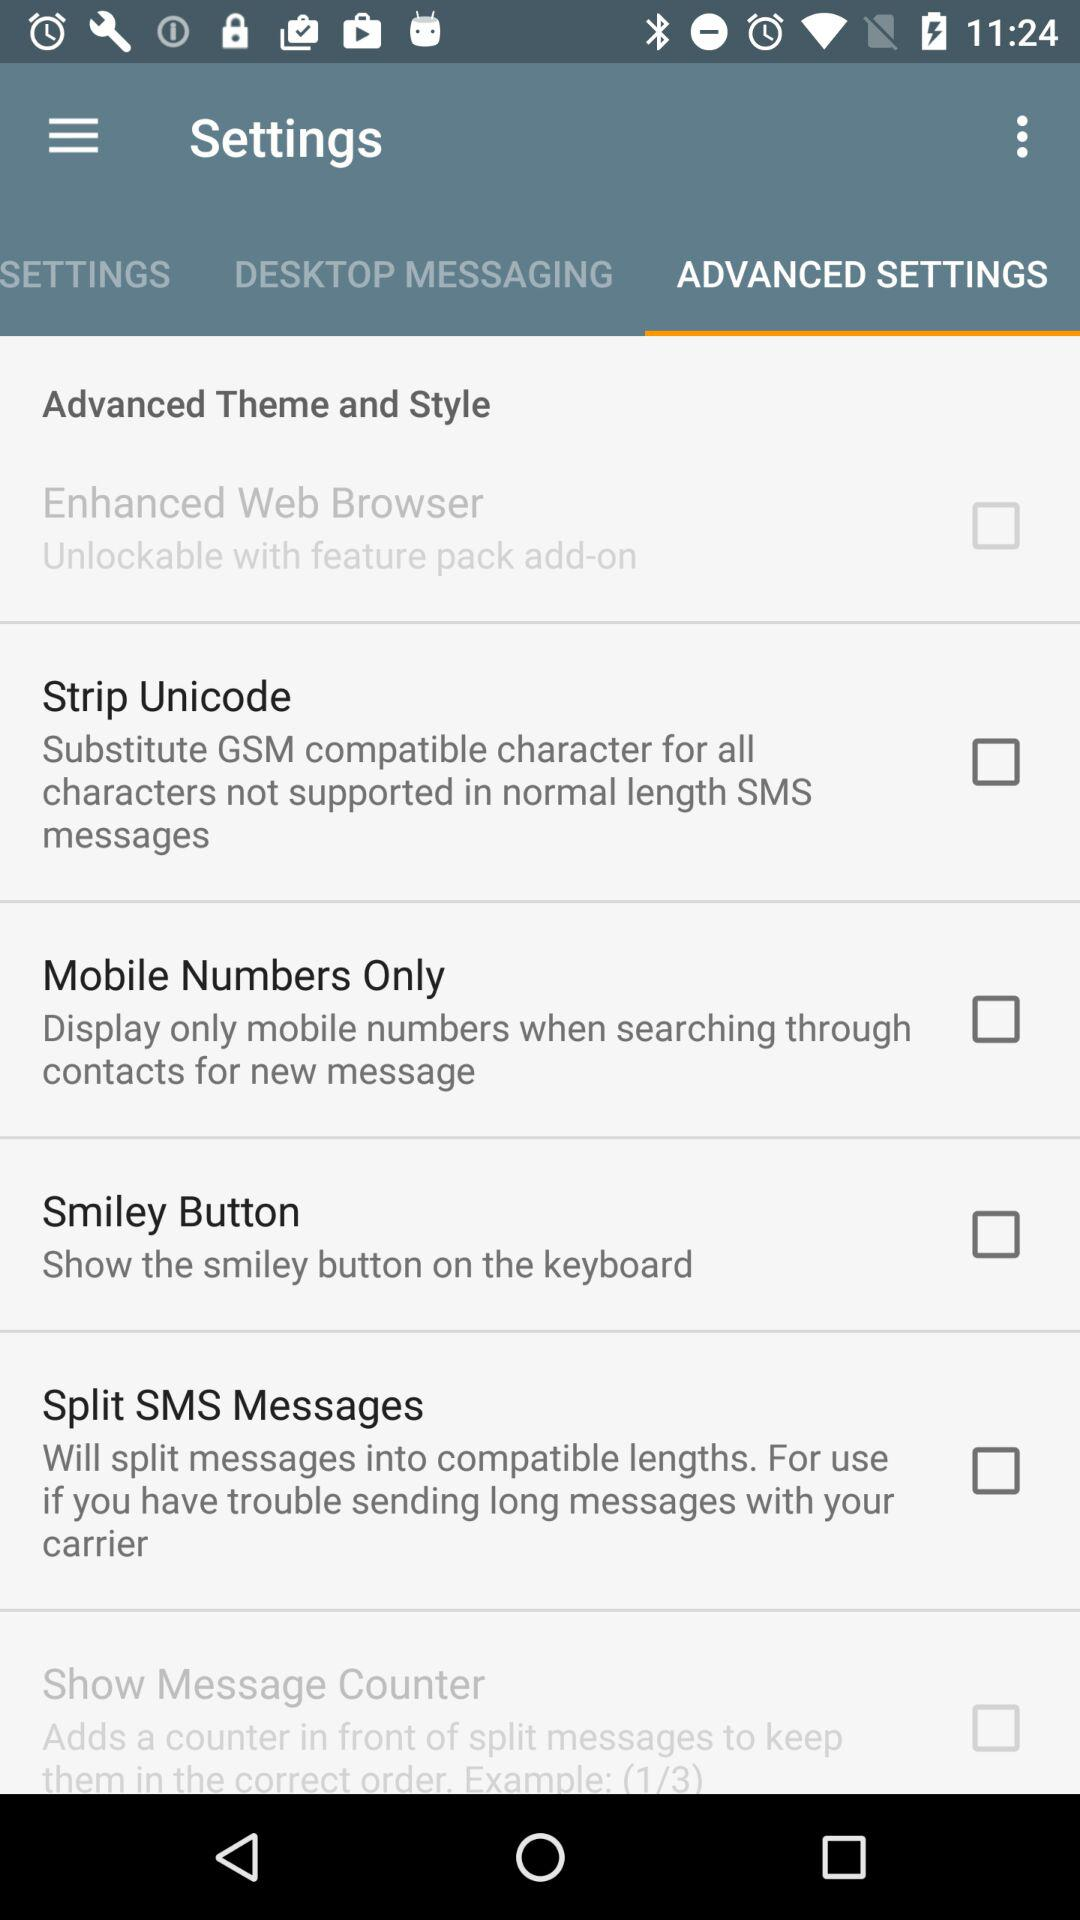The smiley button shows through which thing?
When the provided information is insufficient, respond with <no answer>. <no answer> 